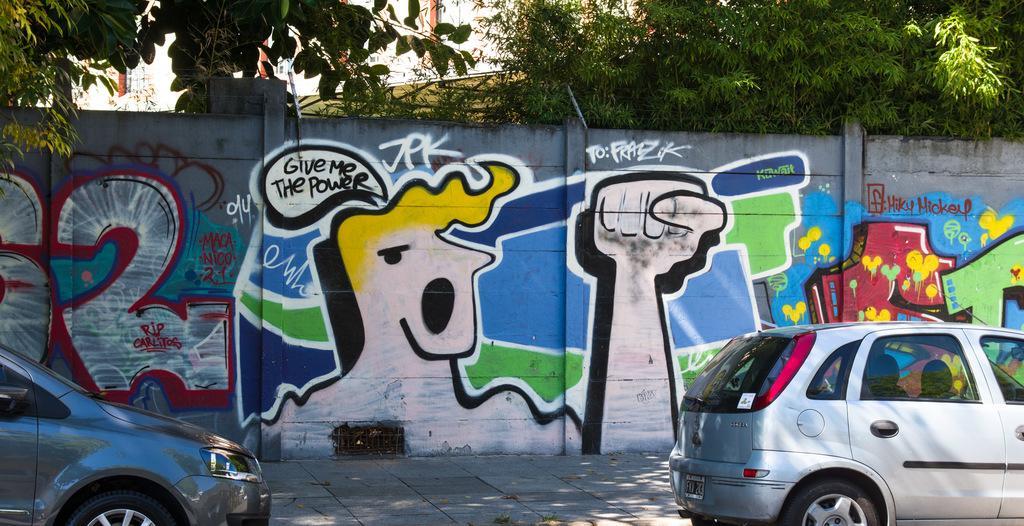Please provide a concise description of this image. In this image in front there are cars. In the background of the image there is a wall with painting on it. There are trees and buildings. 